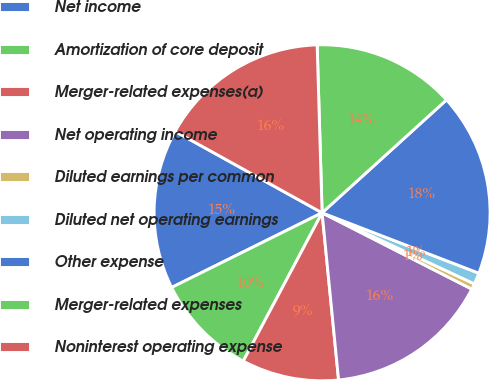<chart> <loc_0><loc_0><loc_500><loc_500><pie_chart><fcel>Net income<fcel>Amortization of core deposit<fcel>Merger-related expenses(a)<fcel>Net operating income<fcel>Diluted earnings per common<fcel>Diluted net operating earnings<fcel>Other expense<fcel>Merger-related expenses<fcel>Noninterest operating expense<nl><fcel>15.38%<fcel>9.89%<fcel>9.34%<fcel>15.93%<fcel>0.55%<fcel>1.1%<fcel>17.58%<fcel>13.74%<fcel>16.48%<nl></chart> 